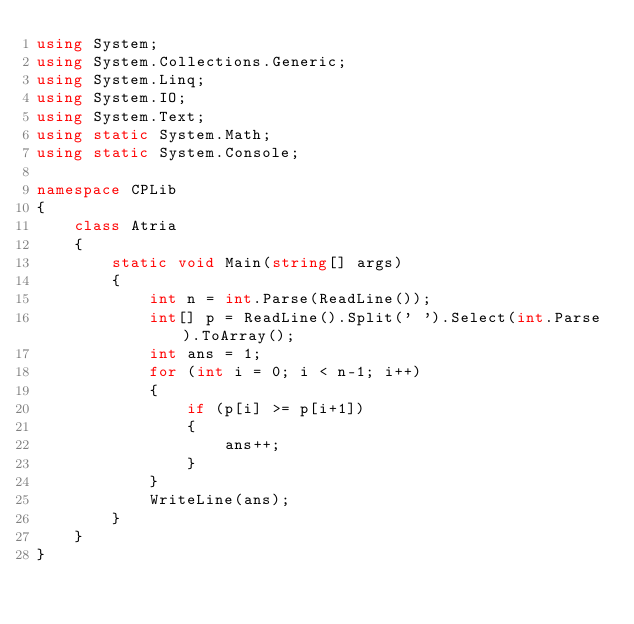<code> <loc_0><loc_0><loc_500><loc_500><_C#_>using System;
using System.Collections.Generic;
using System.Linq;
using System.IO;
using System.Text;
using static System.Math;
using static System.Console;

namespace CPLib
{
    class Atria
    {
        static void Main(string[] args)
        {
            int n = int.Parse(ReadLine());
            int[] p = ReadLine().Split(' ').Select(int.Parse).ToArray();
            int ans = 1;
            for (int i = 0; i < n-1; i++)
            {
                if (p[i] >= p[i+1])
                {
                    ans++;
                }
            }
            WriteLine(ans);
        }
    }
}
</code> 